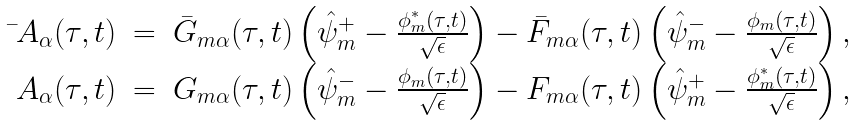Convert formula to latex. <formula><loc_0><loc_0><loc_500><loc_500>\begin{array} { r c l } \bar { \ } A _ { \alpha } ( \tau , t ) & = & \bar { G } _ { m \alpha } ( \tau , t ) \left ( \hat { \psi } _ { m } ^ { + } - \frac { \phi _ { m } ^ { * } ( \tau , t ) } { \sqrt { \epsilon } } \right ) - \bar { F } _ { m \alpha } ( \tau , t ) \left ( \hat { \psi } _ { m } ^ { - } - \frac { \phi _ { m } ( \tau , t ) } { \sqrt { \epsilon } } \right ) , \\ \ A _ { \alpha } ( \tau , t ) & = & G _ { m \alpha } ( \tau , t ) \left ( \hat { \psi } _ { m } ^ { - } - \frac { \phi _ { m } ( \tau , t ) } { \sqrt { \epsilon } } \right ) - F _ { m \alpha } ( \tau , t ) \left ( \hat { \psi } _ { m } ^ { + } - \frac { \phi _ { m } ^ { * } ( \tau , t ) } { \sqrt { \epsilon } } \right ) , \end{array}</formula> 